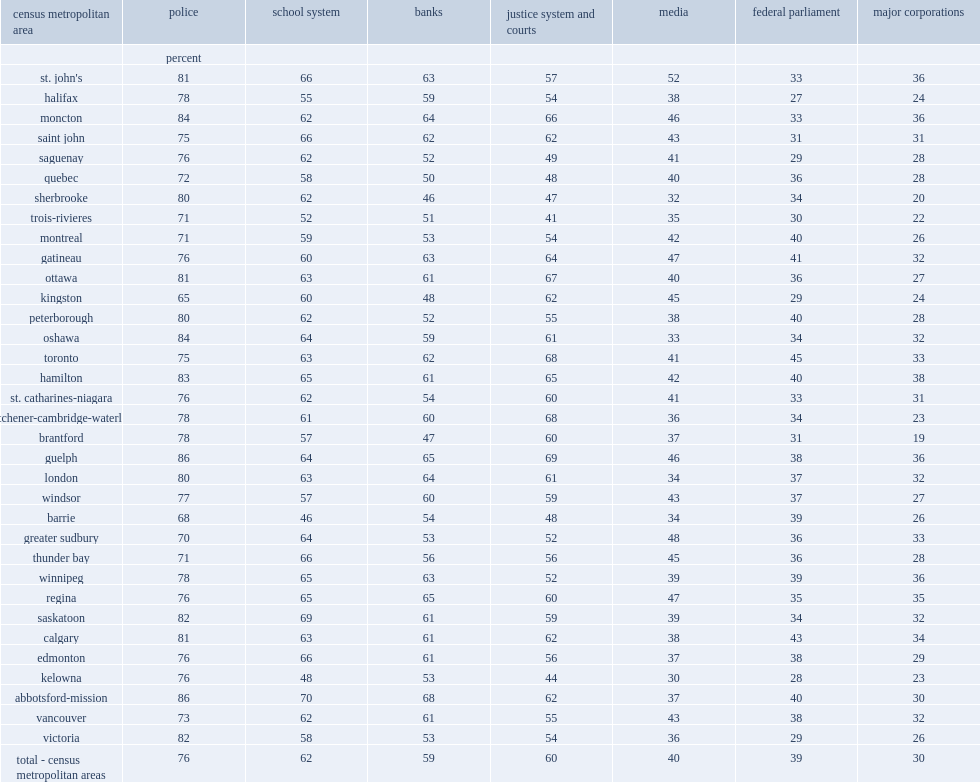Which region has reported the highest confidence in banks? Toronto. What percent of residents of montreal had less confidence than average in police? 71.0. What percent of residents of sherbrooke had lower levels of confidence in banks? 46.0. 